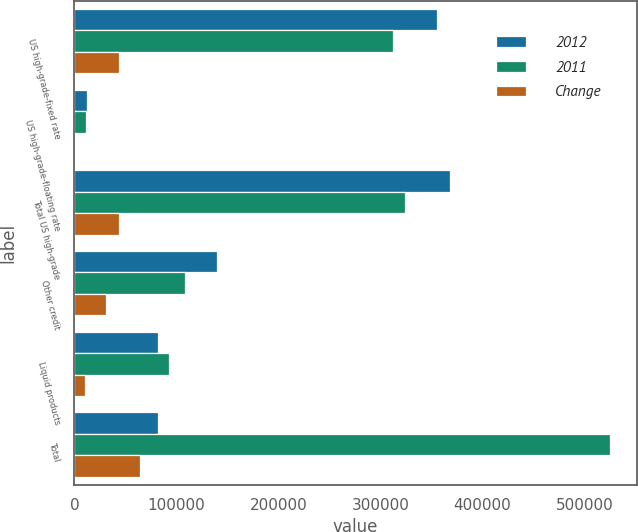Convert chart to OTSL. <chart><loc_0><loc_0><loc_500><loc_500><stacked_bar_chart><ecel><fcel>US high-grade-fixed rate<fcel>US high-grade-floating rate<fcel>Total US high-grade<fcel>Other credit<fcel>Liquid products<fcel>Total<nl><fcel>2012<fcel>355087<fcel>12603<fcel>367690<fcel>139526<fcel>82380<fcel>82380<nl><fcel>2011<fcel>311758<fcel>11802<fcel>323560<fcel>108701<fcel>92746<fcel>525007<nl><fcel>Change<fcel>43329<fcel>801<fcel>44130<fcel>30825<fcel>10366<fcel>64589<nl></chart> 